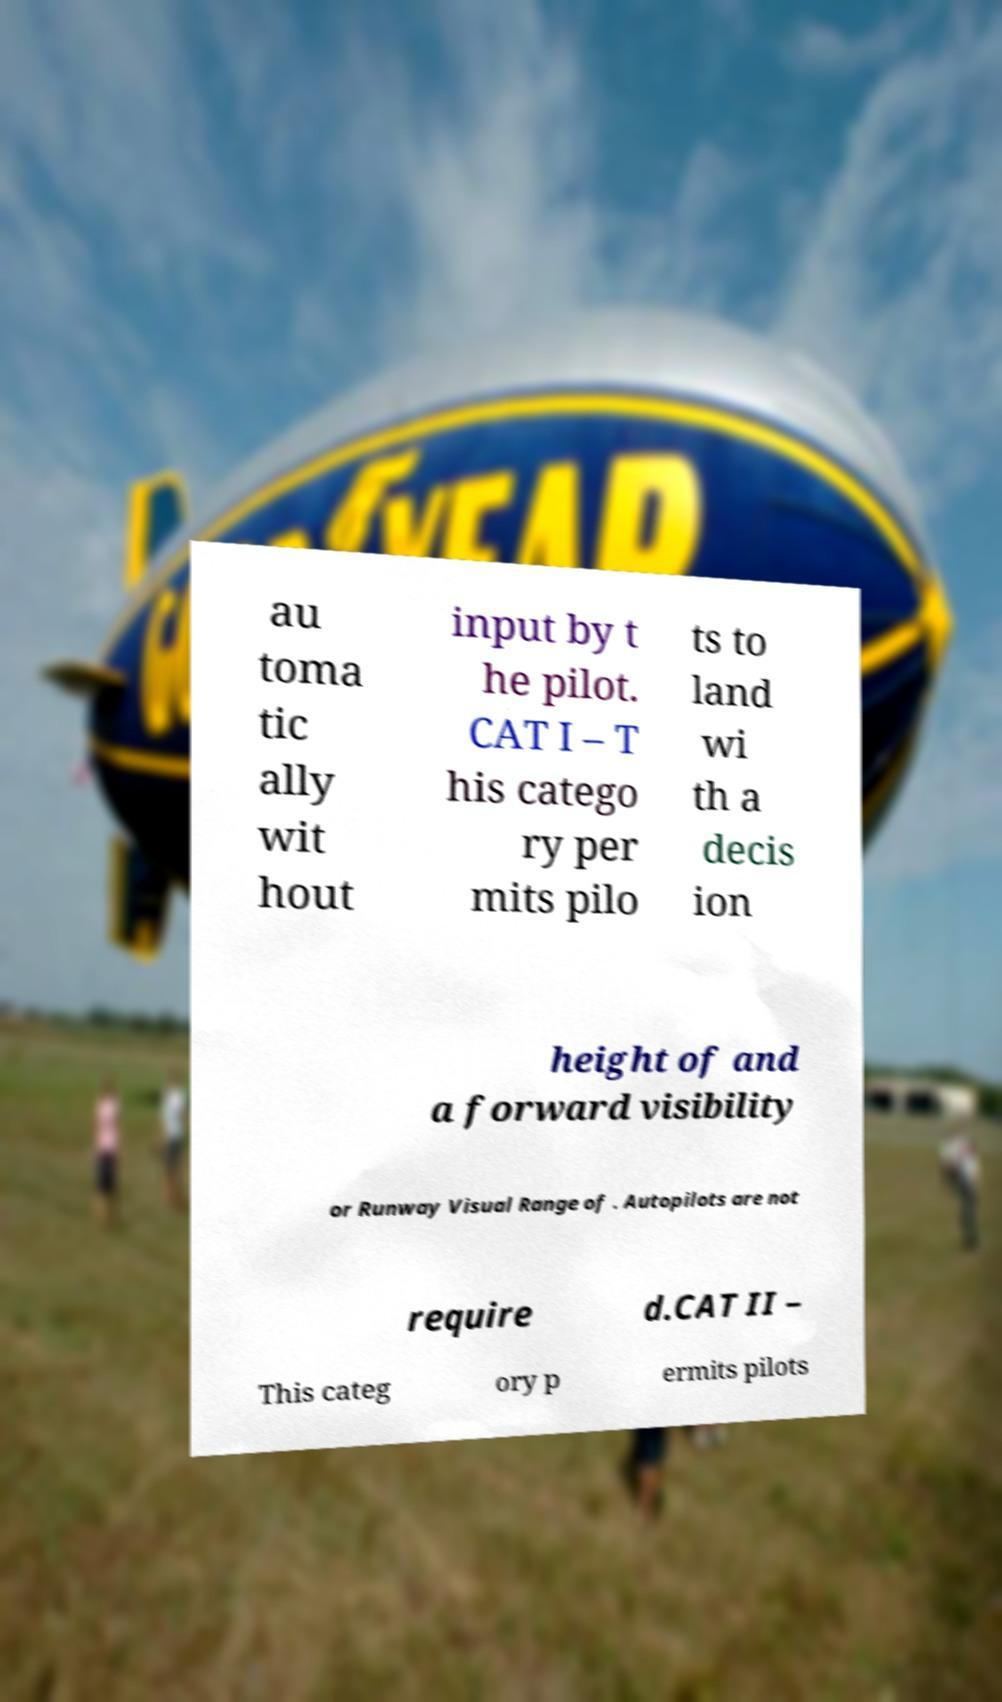Please read and relay the text visible in this image. What does it say? au toma tic ally wit hout input by t he pilot. CAT I – T his catego ry per mits pilo ts to land wi th a decis ion height of and a forward visibility or Runway Visual Range of . Autopilots are not require d.CAT II – This categ ory p ermits pilots 